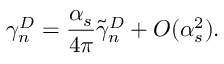Convert formula to latex. <formula><loc_0><loc_0><loc_500><loc_500>\gamma _ { n } ^ { D } = \frac { \alpha _ { s } } { 4 \pi } \tilde { \gamma } _ { n } ^ { D } + O ( \alpha _ { s } ^ { 2 } ) .</formula> 